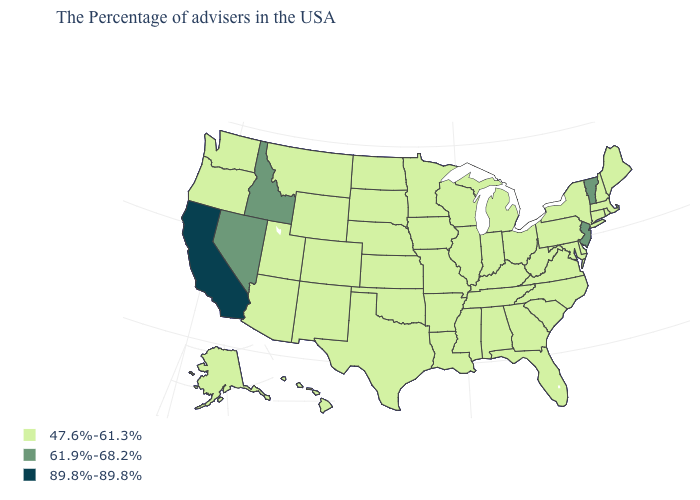Name the states that have a value in the range 47.6%-61.3%?
Short answer required. Maine, Massachusetts, Rhode Island, New Hampshire, Connecticut, New York, Delaware, Maryland, Pennsylvania, Virginia, North Carolina, South Carolina, West Virginia, Ohio, Florida, Georgia, Michigan, Kentucky, Indiana, Alabama, Tennessee, Wisconsin, Illinois, Mississippi, Louisiana, Missouri, Arkansas, Minnesota, Iowa, Kansas, Nebraska, Oklahoma, Texas, South Dakota, North Dakota, Wyoming, Colorado, New Mexico, Utah, Montana, Arizona, Washington, Oregon, Alaska, Hawaii. How many symbols are there in the legend?
Concise answer only. 3. What is the value of Kansas?
Be succinct. 47.6%-61.3%. Name the states that have a value in the range 47.6%-61.3%?
Short answer required. Maine, Massachusetts, Rhode Island, New Hampshire, Connecticut, New York, Delaware, Maryland, Pennsylvania, Virginia, North Carolina, South Carolina, West Virginia, Ohio, Florida, Georgia, Michigan, Kentucky, Indiana, Alabama, Tennessee, Wisconsin, Illinois, Mississippi, Louisiana, Missouri, Arkansas, Minnesota, Iowa, Kansas, Nebraska, Oklahoma, Texas, South Dakota, North Dakota, Wyoming, Colorado, New Mexico, Utah, Montana, Arizona, Washington, Oregon, Alaska, Hawaii. Name the states that have a value in the range 61.9%-68.2%?
Give a very brief answer. Vermont, New Jersey, Idaho, Nevada. What is the highest value in the USA?
Write a very short answer. 89.8%-89.8%. What is the value of Florida?
Concise answer only. 47.6%-61.3%. Does Maryland have a lower value than Washington?
Concise answer only. No. Name the states that have a value in the range 61.9%-68.2%?
Be succinct. Vermont, New Jersey, Idaho, Nevada. Which states hav the highest value in the West?
Keep it brief. California. Which states have the lowest value in the USA?
Quick response, please. Maine, Massachusetts, Rhode Island, New Hampshire, Connecticut, New York, Delaware, Maryland, Pennsylvania, Virginia, North Carolina, South Carolina, West Virginia, Ohio, Florida, Georgia, Michigan, Kentucky, Indiana, Alabama, Tennessee, Wisconsin, Illinois, Mississippi, Louisiana, Missouri, Arkansas, Minnesota, Iowa, Kansas, Nebraska, Oklahoma, Texas, South Dakota, North Dakota, Wyoming, Colorado, New Mexico, Utah, Montana, Arizona, Washington, Oregon, Alaska, Hawaii. What is the lowest value in states that border Missouri?
Give a very brief answer. 47.6%-61.3%. Among the states that border New Mexico , which have the lowest value?
Quick response, please. Oklahoma, Texas, Colorado, Utah, Arizona. Name the states that have a value in the range 47.6%-61.3%?
Give a very brief answer. Maine, Massachusetts, Rhode Island, New Hampshire, Connecticut, New York, Delaware, Maryland, Pennsylvania, Virginia, North Carolina, South Carolina, West Virginia, Ohio, Florida, Georgia, Michigan, Kentucky, Indiana, Alabama, Tennessee, Wisconsin, Illinois, Mississippi, Louisiana, Missouri, Arkansas, Minnesota, Iowa, Kansas, Nebraska, Oklahoma, Texas, South Dakota, North Dakota, Wyoming, Colorado, New Mexico, Utah, Montana, Arizona, Washington, Oregon, Alaska, Hawaii. Does Illinois have a lower value than New Jersey?
Answer briefly. Yes. 